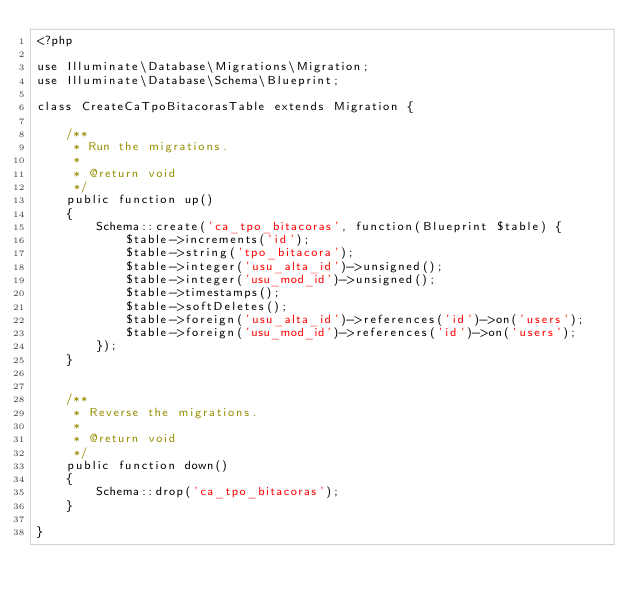<code> <loc_0><loc_0><loc_500><loc_500><_PHP_><?php

use Illuminate\Database\Migrations\Migration;
use Illuminate\Database\Schema\Blueprint;

class CreateCaTpoBitacorasTable extends Migration {

	/**
	 * Run the migrations.
	 *
	 * @return void
	 */
	public function up()
	{
		Schema::create('ca_tpo_bitacoras', function(Blueprint $table) {
			$table->increments('id');
			$table->string('tpo_bitacora');
			$table->integer('usu_alta_id')->unsigned();
			$table->integer('usu_mod_id')->unsigned();
			$table->timestamps();
			$table->softDeletes();
			$table->foreign('usu_alta_id')->references('id')->on('users');
			$table->foreign('usu_mod_id')->references('id')->on('users');
		});
	}


	/**
	 * Reverse the migrations.
	 *
	 * @return void
	 */
	public function down()
	{
		Schema::drop('ca_tpo_bitacoras');
	}

}
</code> 